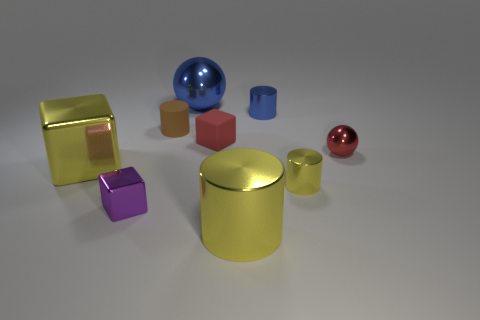Subtract 1 cylinders. How many cylinders are left? 3 Add 1 large matte objects. How many objects exist? 10 Subtract all cylinders. How many objects are left? 5 Subtract all small metallic balls. Subtract all small metal cylinders. How many objects are left? 6 Add 1 small purple shiny things. How many small purple shiny things are left? 2 Add 8 cyan matte objects. How many cyan matte objects exist? 8 Subtract 0 gray balls. How many objects are left? 9 